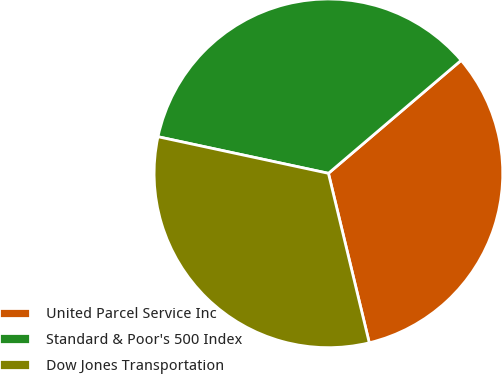Convert chart to OTSL. <chart><loc_0><loc_0><loc_500><loc_500><pie_chart><fcel>United Parcel Service Inc<fcel>Standard & Poor's 500 Index<fcel>Dow Jones Transportation<nl><fcel>32.46%<fcel>35.41%<fcel>32.13%<nl></chart> 